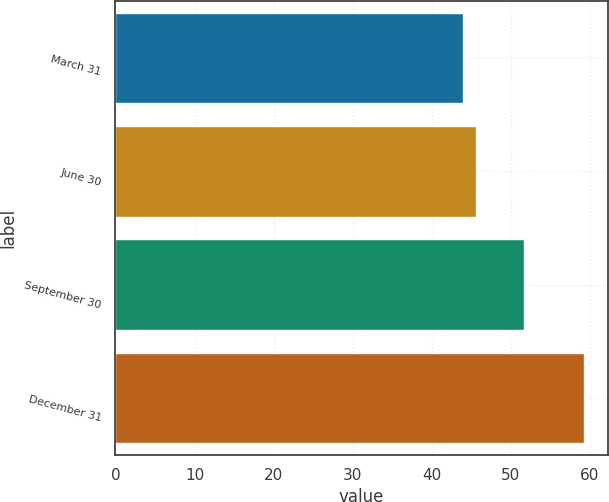Convert chart to OTSL. <chart><loc_0><loc_0><loc_500><loc_500><bar_chart><fcel>March 31<fcel>June 30<fcel>September 30<fcel>December 31<nl><fcel>43.96<fcel>45.58<fcel>51.6<fcel>59.28<nl></chart> 